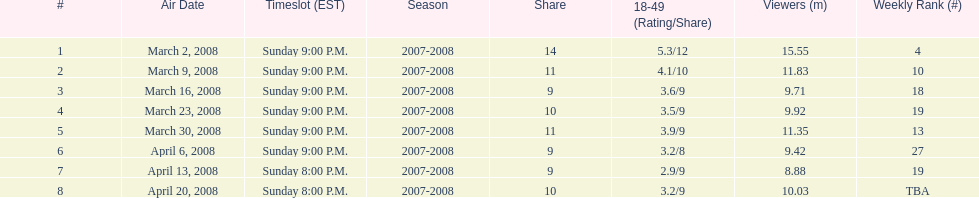Did the season finish at an earlier or later timeslot? Earlier. 